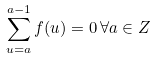<formula> <loc_0><loc_0><loc_500><loc_500>\sum _ { u = a } ^ { a - 1 } f ( u ) = 0 \, \forall { a \in Z }</formula> 